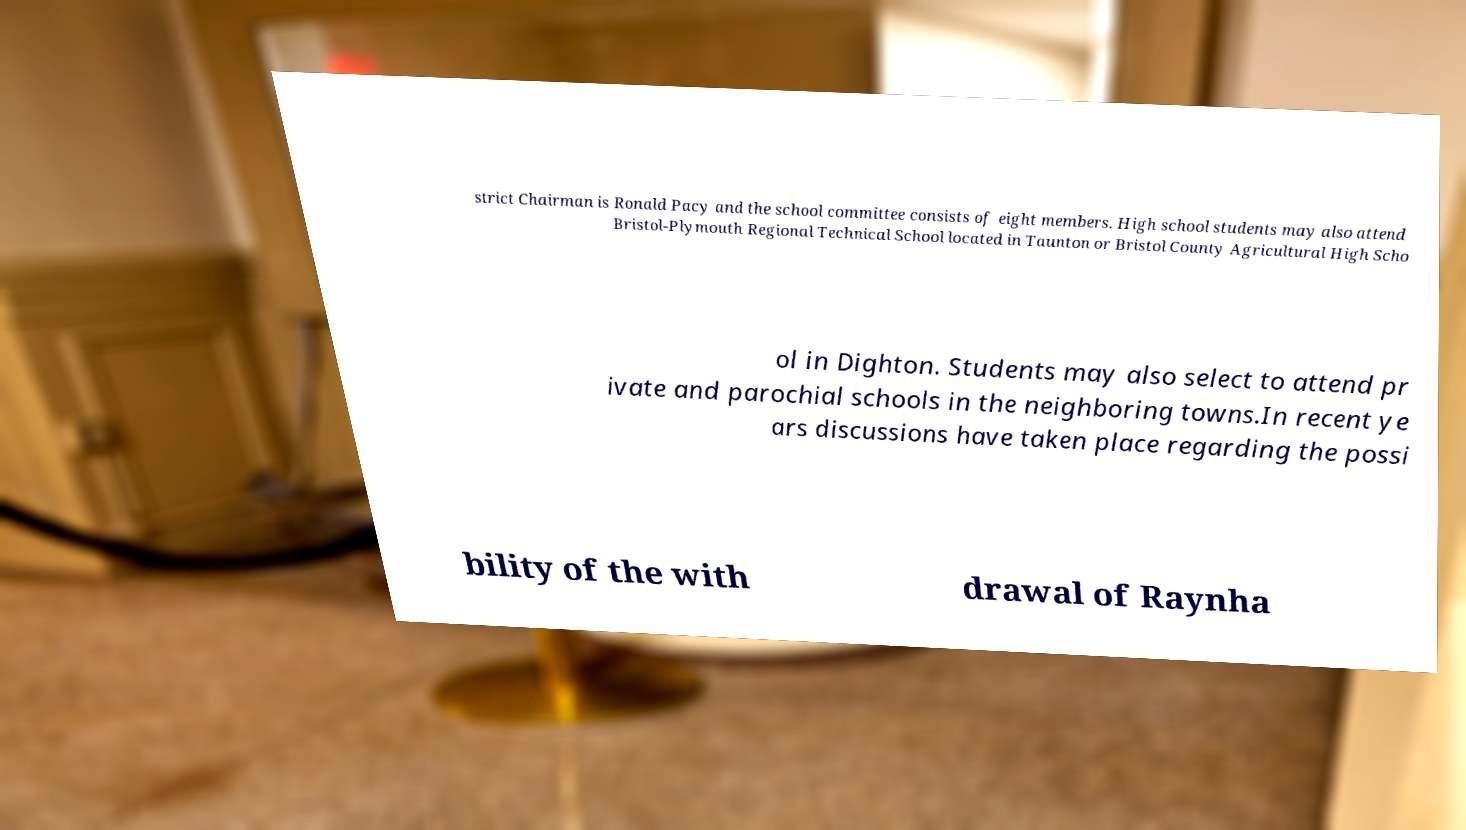There's text embedded in this image that I need extracted. Can you transcribe it verbatim? strict Chairman is Ronald Pacy and the school committee consists of eight members. High school students may also attend Bristol-Plymouth Regional Technical School located in Taunton or Bristol County Agricultural High Scho ol in Dighton. Students may also select to attend pr ivate and parochial schools in the neighboring towns.In recent ye ars discussions have taken place regarding the possi bility of the with drawal of Raynha 